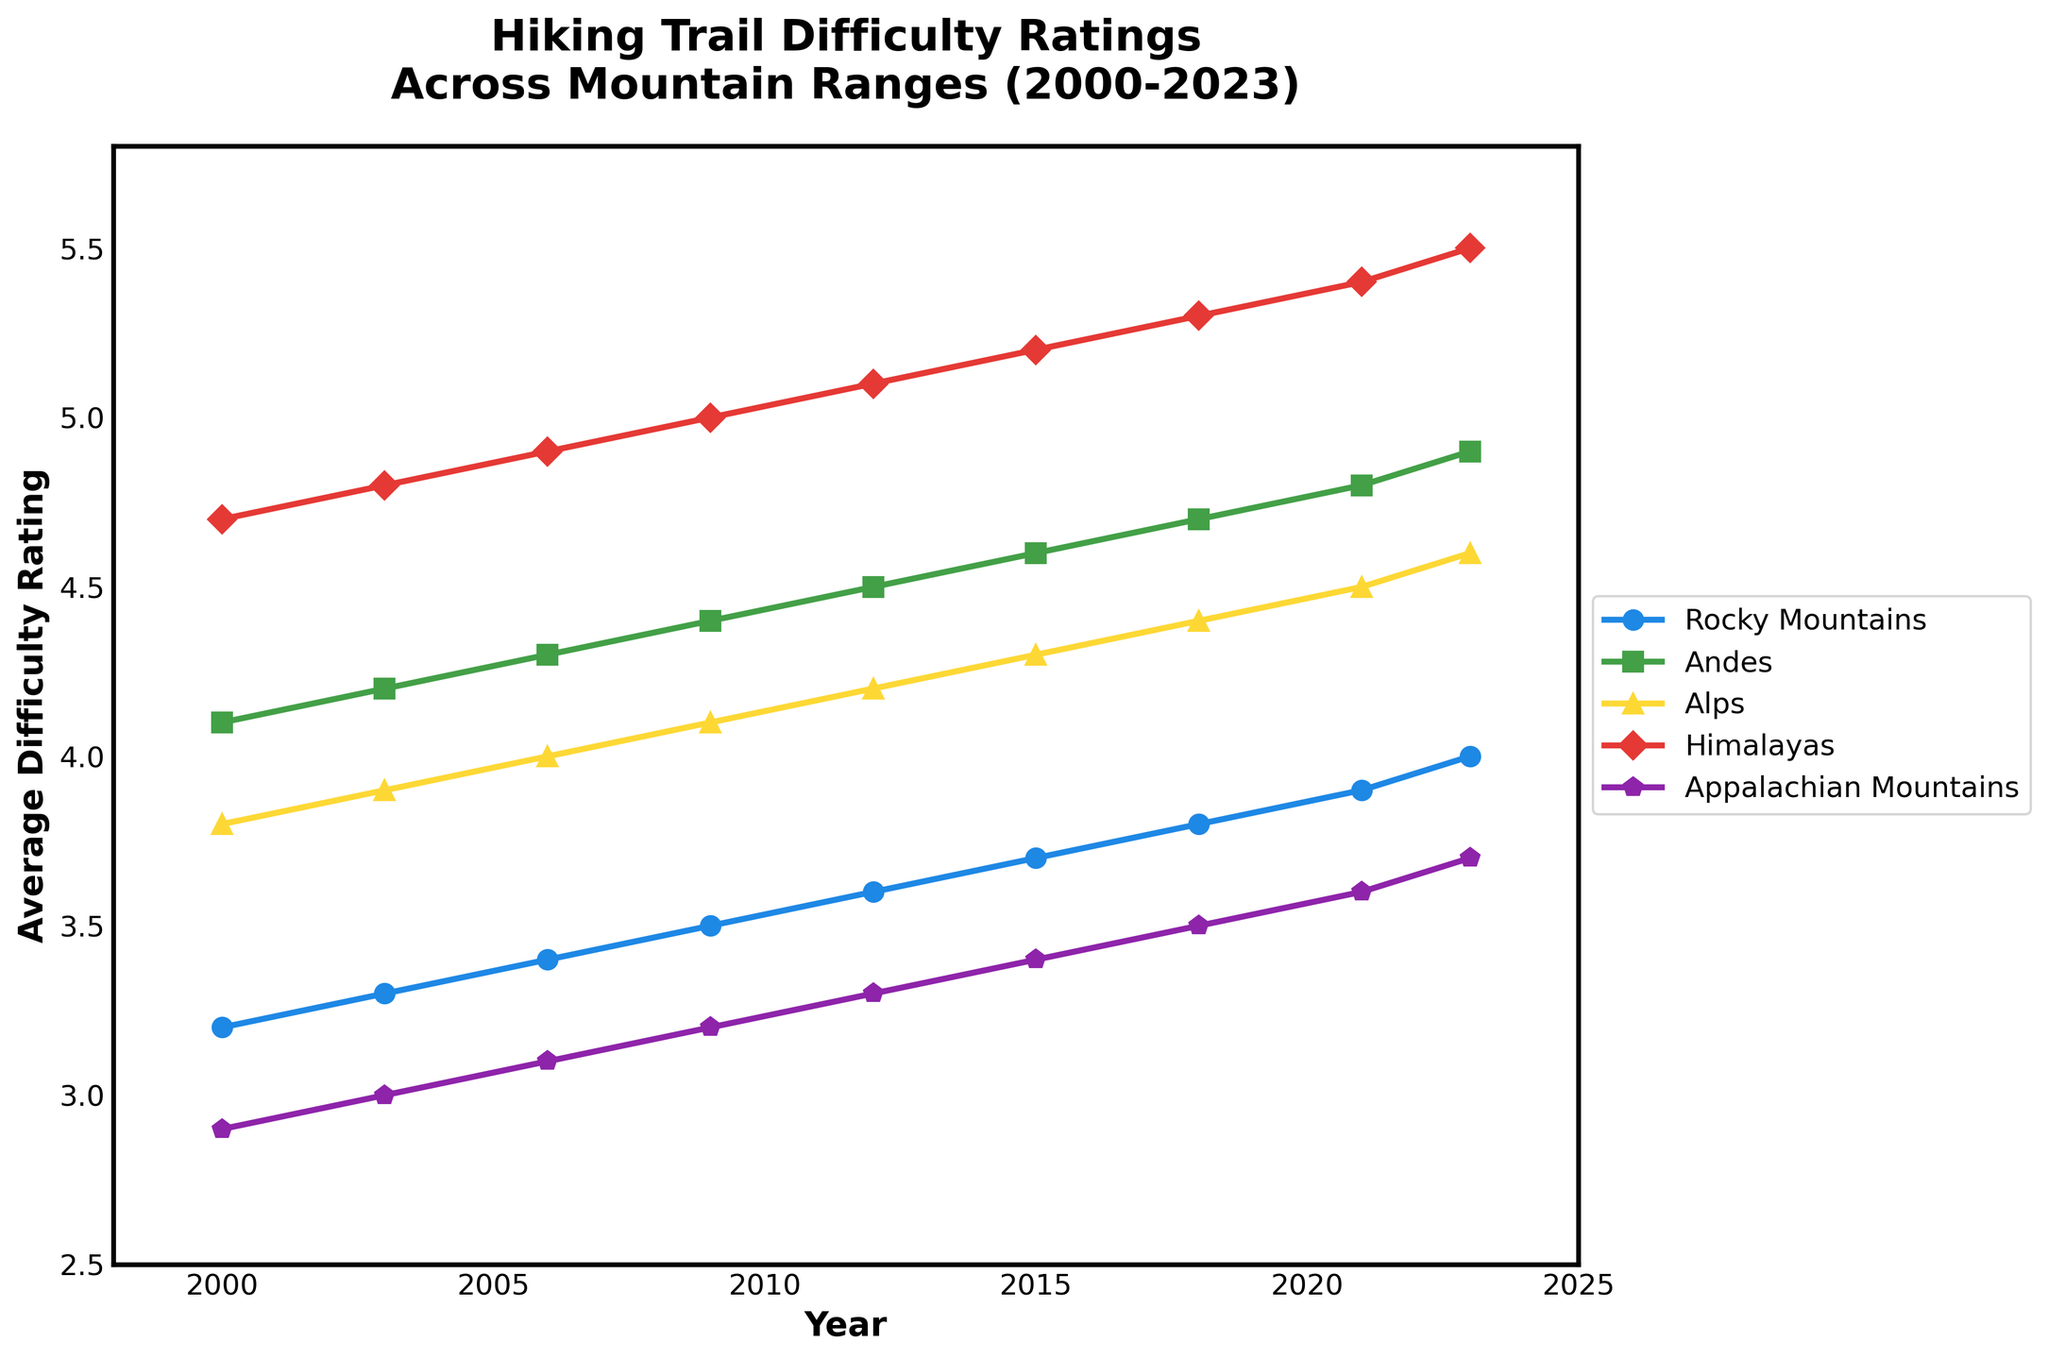What year did the Appalachian Mountains' difficulty rating reach 3.5? Look for the data point where the Appalachian Mountains' rating is 3.5. According to the chart, this occurs in 2018.
Answer: 2018 Which mountain range started with the highest difficulty rating in the year 2000? Examine the ratings in the year 2000 for all mountain ranges. The Himalayas had the highest rating at 4.7.
Answer: Himalayas How much did the Andes' difficulty rating increase from 2000 to 2023? Subtract the difficulty rating of the Andes in 2000 (4.1) from its rating in 2023 (4.9). The increase is 4.9 - 4.1 = 0.8.
Answer: 0.8 What is the difference between the rating of the Rockies and the Alps in 2023? Subtract the Alps' rating in 2023 (4.6) from the Rockies' rating in 2023 (4.0). The difference is 4.0 - 4.6 = -0.6, or 0.6 when considering absolute value.
Answer: 0.6 Which mountain range showed the highest increase in difficulty rating from 2000 to 2023? Calculate the increase for each range and compare: 
- Rockies: 4.0 - 3.2 = 0.8
- Andes: 4.9 - 4.1 = 0.8
- Alps: 4.6 - 3.8 = 0.8
- Himalayas: 5.5 - 4.7 = 0.8
- Appalachian: 3.7 - 2.9 = 0.8
All ranges increased by 0.8, so they all showed the highest increase.
Answer: All ranges (0.8 increase each) What is the combined average difficulty rating of the Himalayas and Andes in 2023? Add the Himalayas' rating (5.5) and Andes' rating (4.9) in 2023, then divide by 2: (5.5 + 4.9)/2 = 10.4/2 = 5.2.
Answer: 5.2 Between which years did the Rockies' difficulty rating increase the most? Compare the increases in the Rockies' ratings across the intervals:
- 2000-2003: 3.3 - 3.2 = 0.1
- 2003-2006: 3.4 - 3.3 = 0.1
- 2006-2009: 3.5 - 3.4 = 0.1
- 2009-2012: 3.6 - 3.5 = 0.1
- 2012-2015: 3.7 - 3.6 = 0.1
- 2015-2018: 3.8 - 3.7 = 0.1
- 2018-2021: 3.9 - 3.8 = 0.1
- 2021-2023: 4.0 - 3.9 = 0.1
The rating increased equally by 0.1 across all intervals.
Answer: All intervals (0.1 increase each) In which year did the Alps' difficulty rating reach or exceed 4.5 for the first time? Identify when the Alps' rating reached 4.5 or higher. It first occurred in 2021.
Answer: 2021 How did the average trail difficulty across all ranges change from 2000 to 2023? Calculate the average rating for each year and compare:
- 2000: (3.2 + 4.1 + 3.8 + 4.7 + 2.9)/5 = 3.74
- 2023: (4.0 + 4.9 + 4.6 + 5.5 + 3.7)/5 = 4.54
The average increased from 3.74 to 4.54.
Answer: Increased Which mountain range always had a higher difficulty rating than the Appalachian Mountains across the years? Compare the ratings for each year from all ranges with those of the Appalachian Mountains. All ranges (Rocky Mountains, Andes, Alps, Himalayas) consistently had higher ratings than the Appalachian Mountains from 2000 to 2023.
Answer: All other ranges 